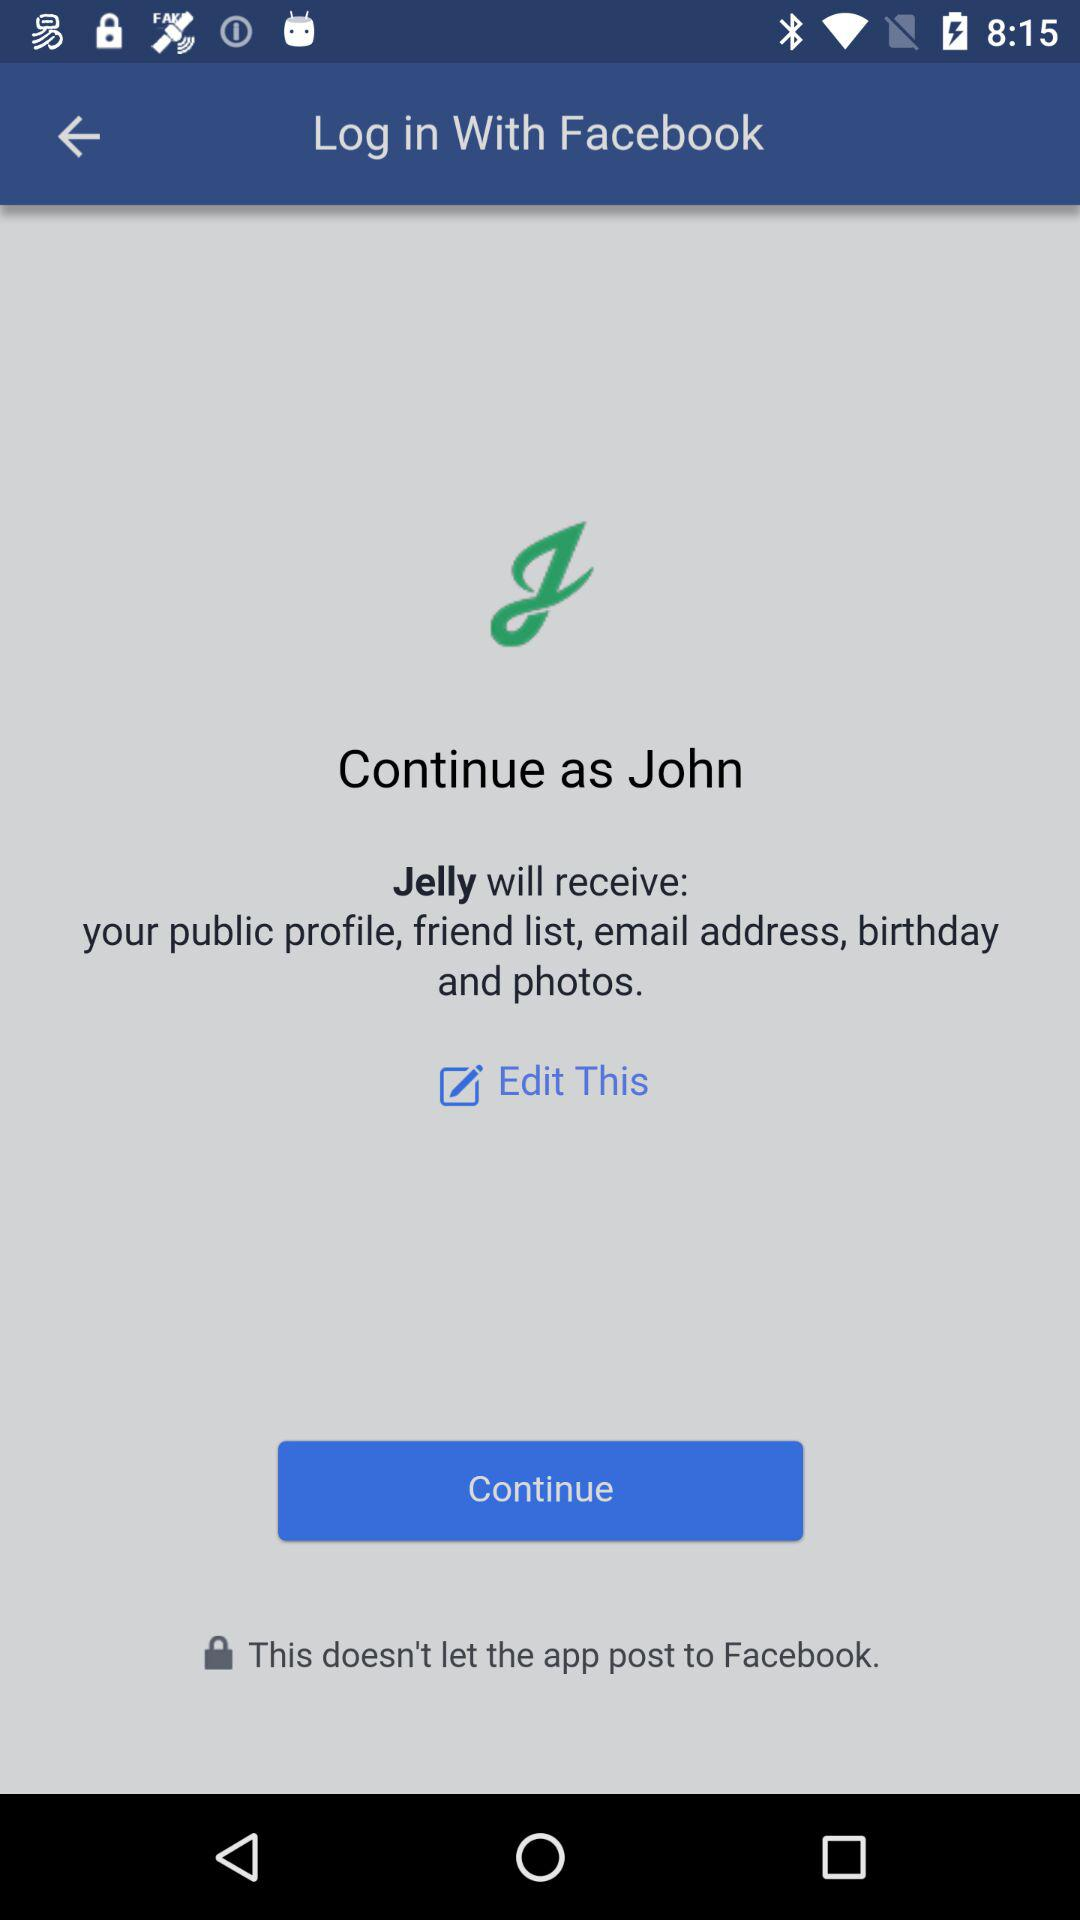What is the user's name? The user's name is John. 